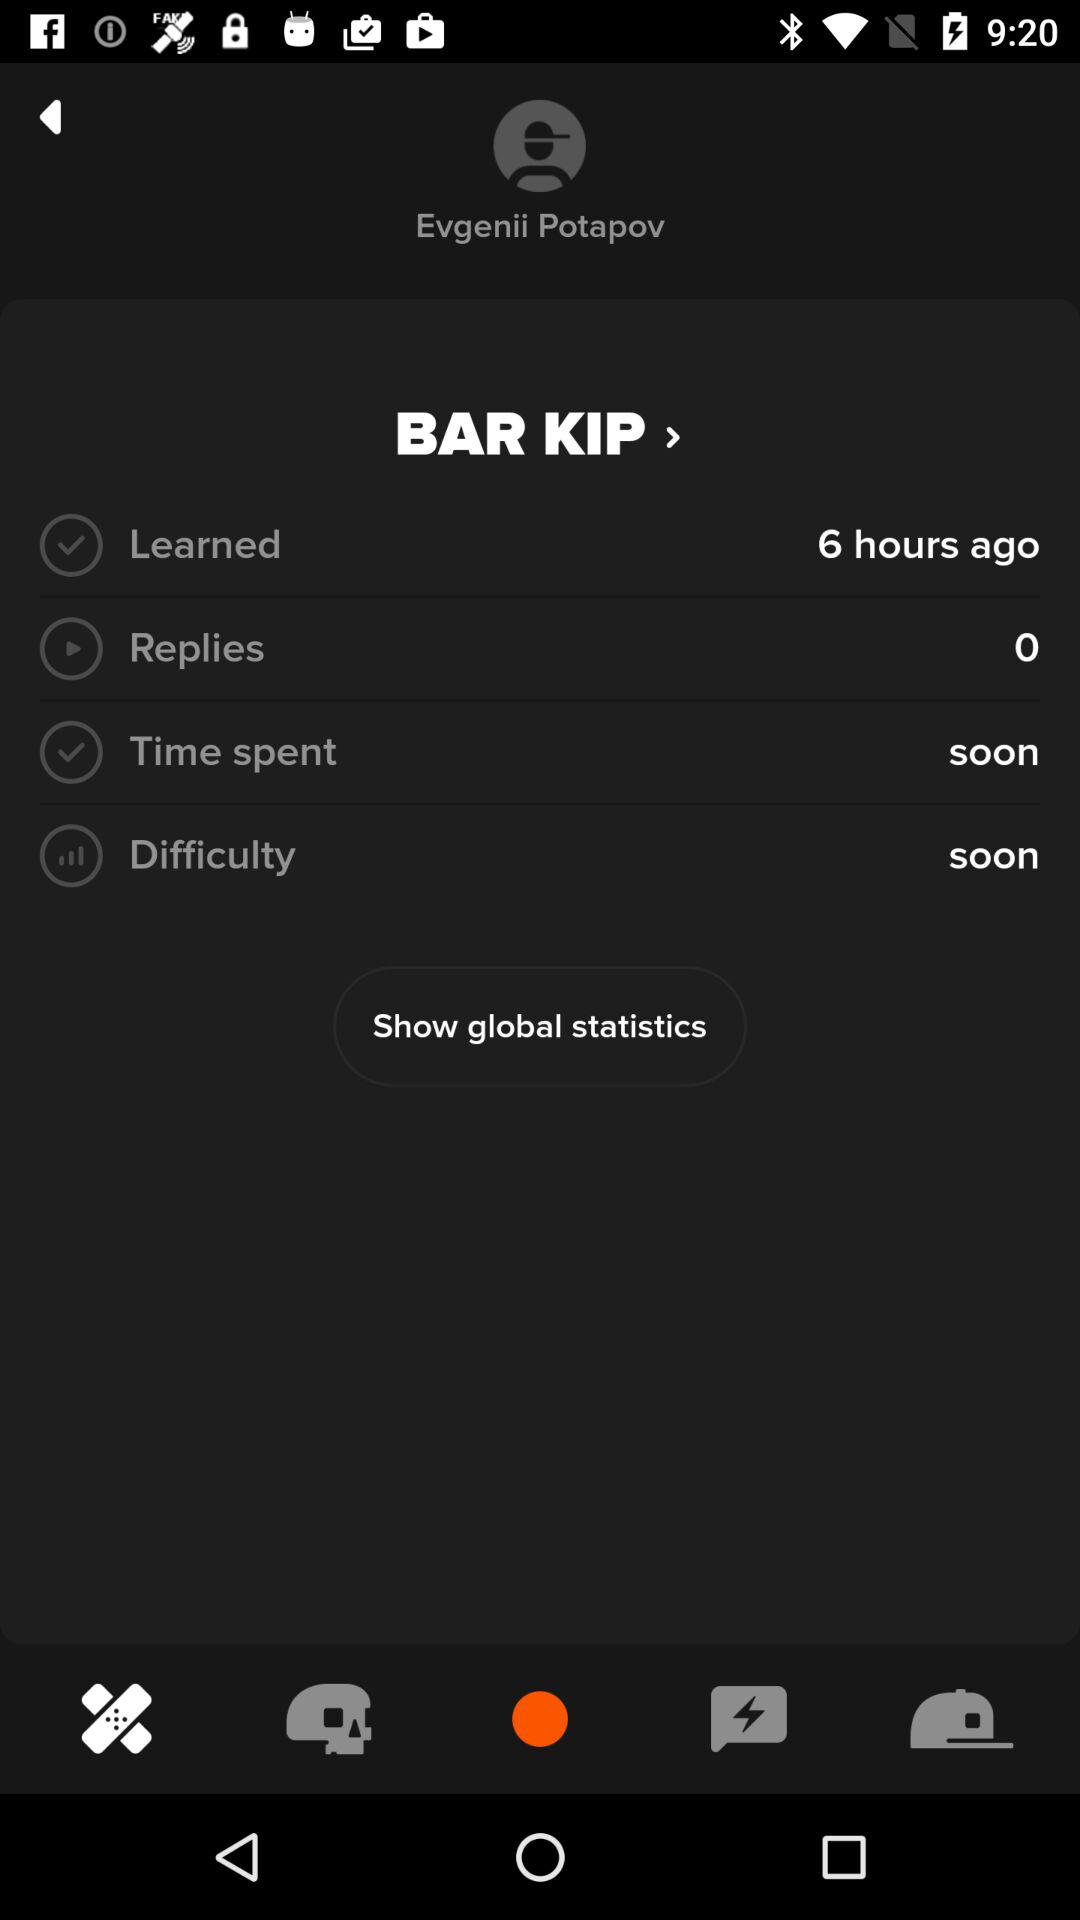How many more hours ago was the learned item updated than the replies item?
Answer the question using a single word or phrase. 6 